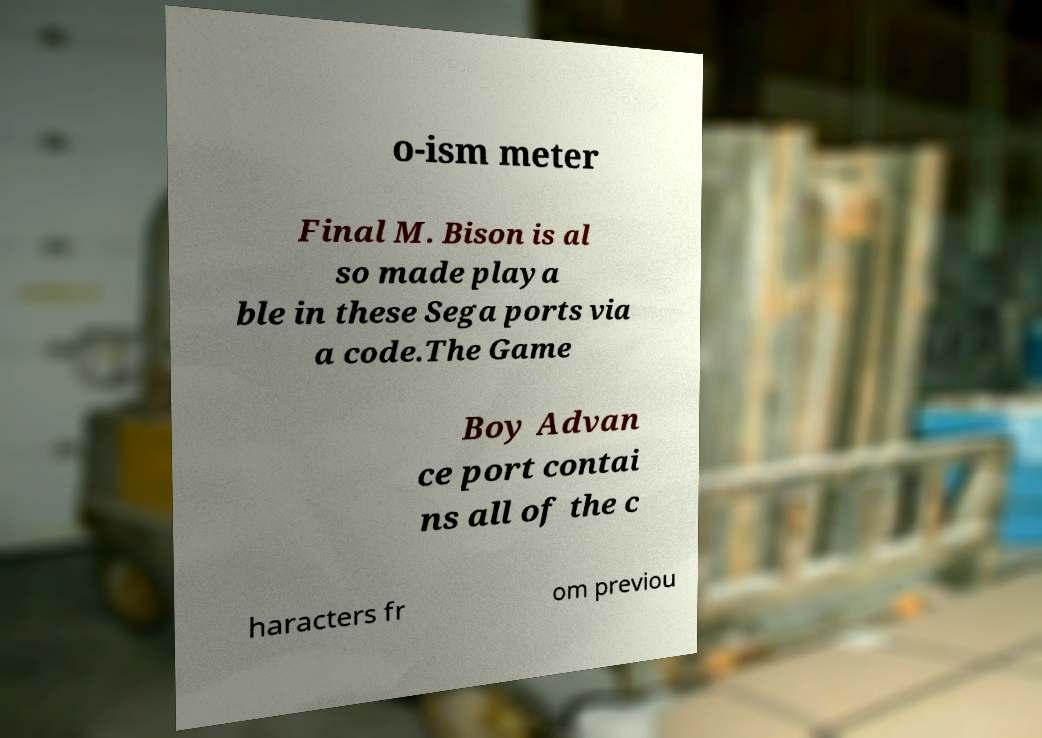I need the written content from this picture converted into text. Can you do that? o-ism meter Final M. Bison is al so made playa ble in these Sega ports via a code.The Game Boy Advan ce port contai ns all of the c haracters fr om previou 